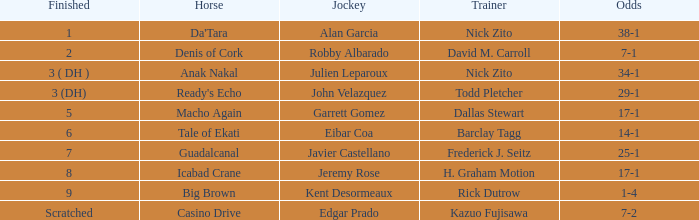Who is the equestrian for guadalcanal? Javier Castellano. Give me the full table as a dictionary. {'header': ['Finished', 'Horse', 'Jockey', 'Trainer', 'Odds'], 'rows': [['1', "Da'Tara", 'Alan Garcia', 'Nick Zito', '38-1'], ['2', 'Denis of Cork', 'Robby Albarado', 'David M. Carroll', '7-1'], ['3 ( DH )', 'Anak Nakal', 'Julien Leparoux', 'Nick Zito', '34-1'], ['3 (DH)', "Ready's Echo", 'John Velazquez', 'Todd Pletcher', '29-1'], ['5', 'Macho Again', 'Garrett Gomez', 'Dallas Stewart', '17-1'], ['6', 'Tale of Ekati', 'Eibar Coa', 'Barclay Tagg', '14-1'], ['7', 'Guadalcanal', 'Javier Castellano', 'Frederick J. Seitz', '25-1'], ['8', 'Icabad Crane', 'Jeremy Rose', 'H. Graham Motion', '17-1'], ['9', 'Big Brown', 'Kent Desormeaux', 'Rick Dutrow', '1-4'], ['Scratched', 'Casino Drive', 'Edgar Prado', 'Kazuo Fujisawa', '7-2']]} 